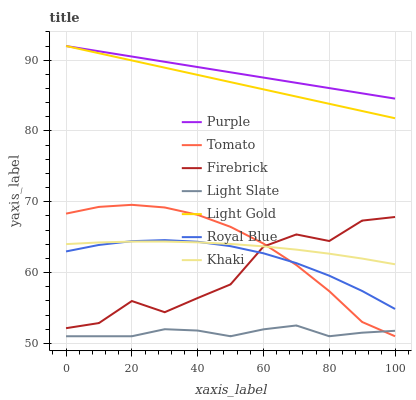Does Light Slate have the minimum area under the curve?
Answer yes or no. Yes. Does Purple have the maximum area under the curve?
Answer yes or no. Yes. Does Khaki have the minimum area under the curve?
Answer yes or no. No. Does Khaki have the maximum area under the curve?
Answer yes or no. No. Is Purple the smoothest?
Answer yes or no. Yes. Is Firebrick the roughest?
Answer yes or no. Yes. Is Khaki the smoothest?
Answer yes or no. No. Is Khaki the roughest?
Answer yes or no. No. Does Tomato have the lowest value?
Answer yes or no. Yes. Does Khaki have the lowest value?
Answer yes or no. No. Does Light Gold have the highest value?
Answer yes or no. Yes. Does Khaki have the highest value?
Answer yes or no. No. Is Light Slate less than Royal Blue?
Answer yes or no. Yes. Is Light Gold greater than Light Slate?
Answer yes or no. Yes. Does Royal Blue intersect Tomato?
Answer yes or no. Yes. Is Royal Blue less than Tomato?
Answer yes or no. No. Is Royal Blue greater than Tomato?
Answer yes or no. No. Does Light Slate intersect Royal Blue?
Answer yes or no. No. 